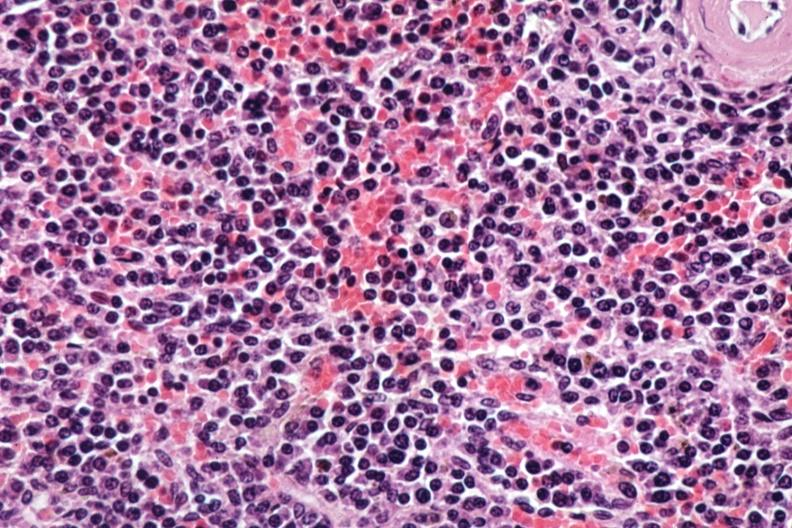what is present?
Answer the question using a single word or phrase. Spleen 